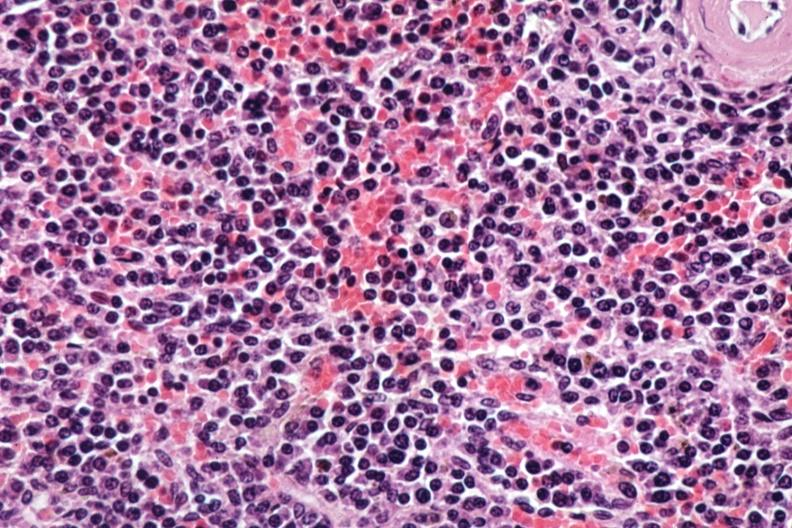what is present?
Answer the question using a single word or phrase. Spleen 